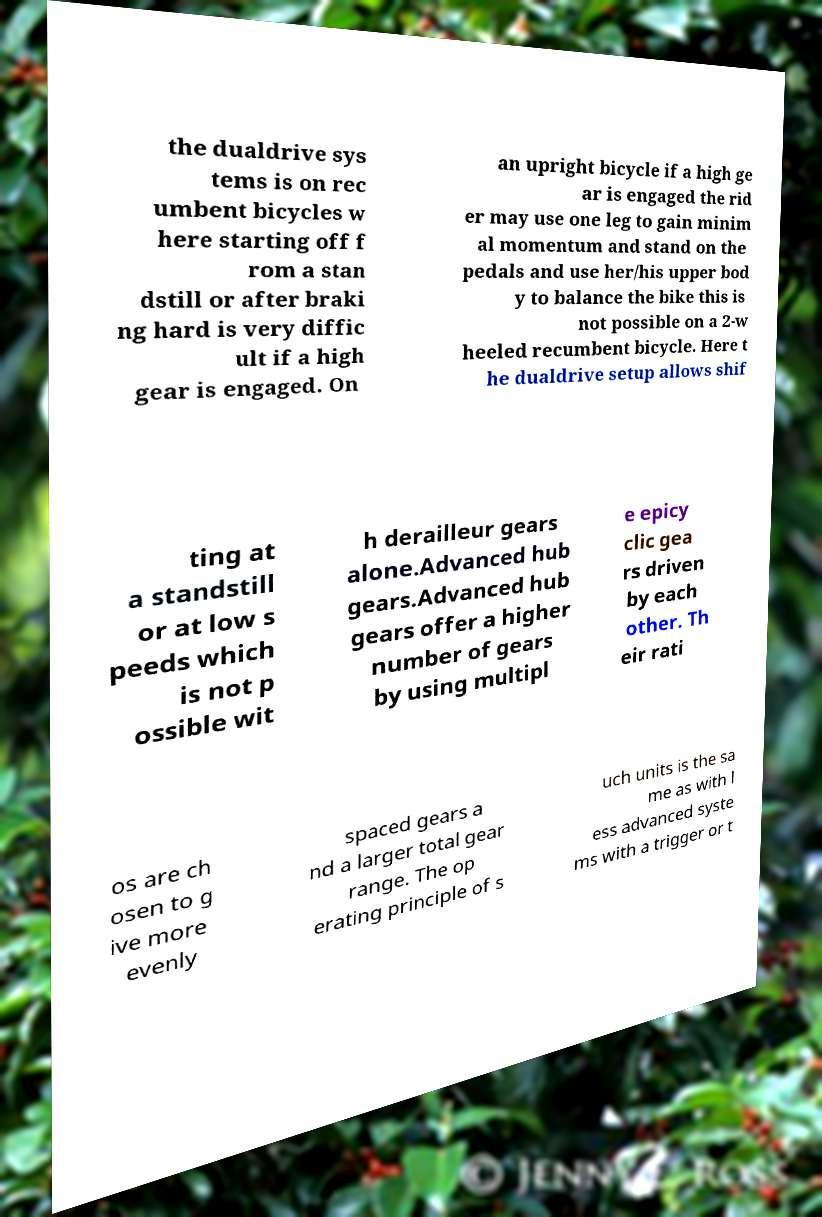Could you extract and type out the text from this image? the dualdrive sys tems is on rec umbent bicycles w here starting off f rom a stan dstill or after braki ng hard is very diffic ult if a high gear is engaged. On an upright bicycle if a high ge ar is engaged the rid er may use one leg to gain minim al momentum and stand on the pedals and use her/his upper bod y to balance the bike this is not possible on a 2-w heeled recumbent bicycle. Here t he dualdrive setup allows shif ting at a standstill or at low s peeds which is not p ossible wit h derailleur gears alone.Advanced hub gears.Advanced hub gears offer a higher number of gears by using multipl e epicy clic gea rs driven by each other. Th eir rati os are ch osen to g ive more evenly spaced gears a nd a larger total gear range. The op erating principle of s uch units is the sa me as with l ess advanced syste ms with a trigger or t 